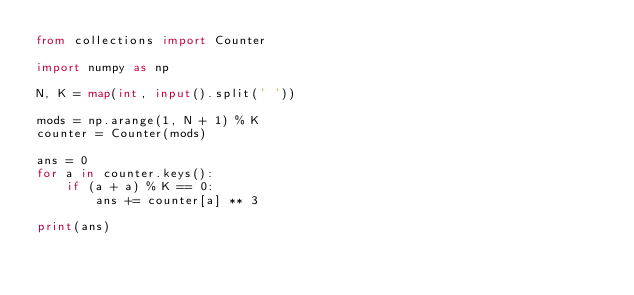<code> <loc_0><loc_0><loc_500><loc_500><_Python_>from collections import Counter

import numpy as np

N, K = map(int, input().split(' '))

mods = np.arange(1, N + 1) % K
counter = Counter(mods)

ans = 0
for a in counter.keys():
    if (a + a) % K == 0:
        ans += counter[a] ** 3

print(ans)
</code> 